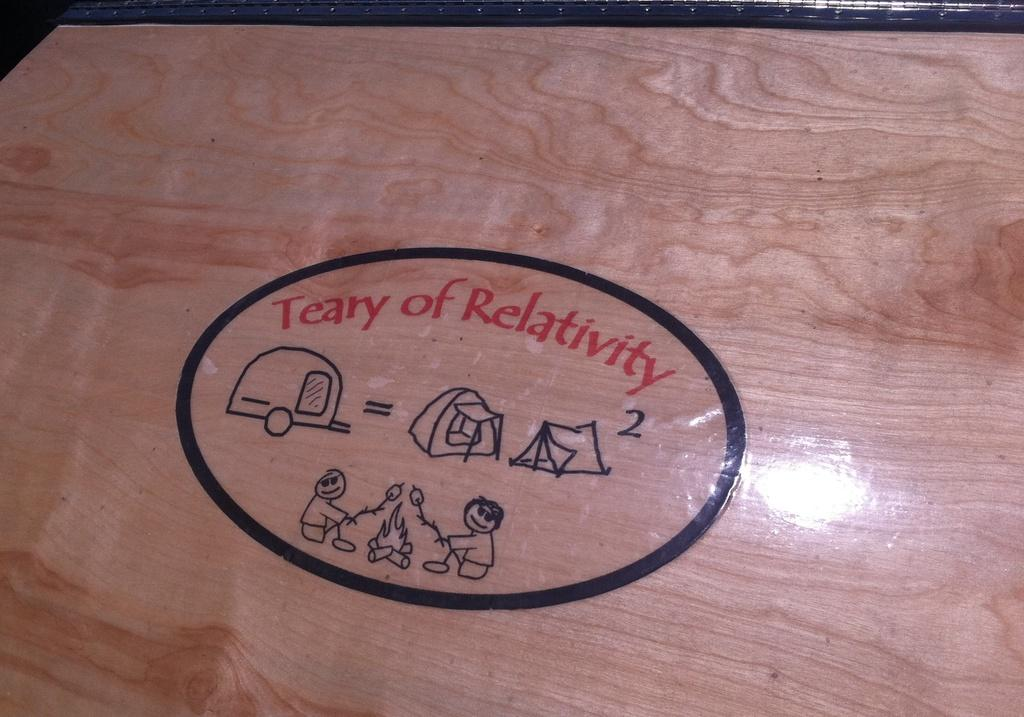What is the main object in the image? There is a wooden plank in the image. What is written or depicted on the wooden plank? There is text on the wooden plank. What type of structures can be seen in the image? There are images of tents in the image. What mode of transportation is depicted in the image? There is an image of a vehicle in the image. How many people are shown in the image? There are two persons depicted in the image. What is the source of light or heat in the image? There is an image of fire in the image. What type of clouds can be seen in the image? There are no clouds present in the image. What type of destruction is depicted in the image? There is no destruction depicted in the image; it features a wooden plank with text and images, as well as a vehicle, tents, and people. 